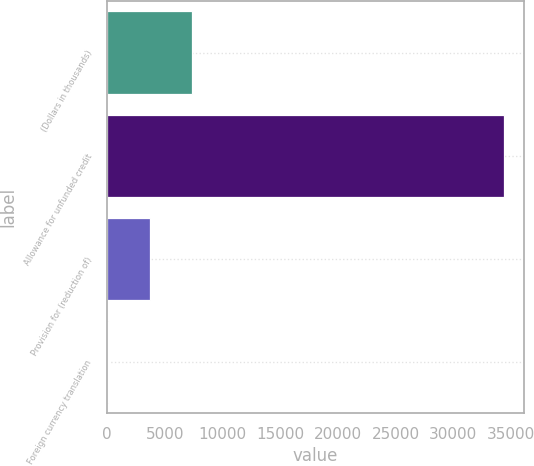<chart> <loc_0><loc_0><loc_500><loc_500><bar_chart><fcel>(Dollars in thousands)<fcel>Allowance for unfunded credit<fcel>Provision for (reduction of)<fcel>Foreign currency translation<nl><fcel>7330.2<fcel>34415<fcel>3694.1<fcel>58<nl></chart> 